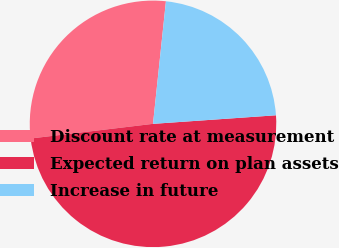Convert chart. <chart><loc_0><loc_0><loc_500><loc_500><pie_chart><fcel>Discount rate at measurement<fcel>Expected return on plan assets<fcel>Increase in future<nl><fcel>28.57%<fcel>49.21%<fcel>22.22%<nl></chart> 